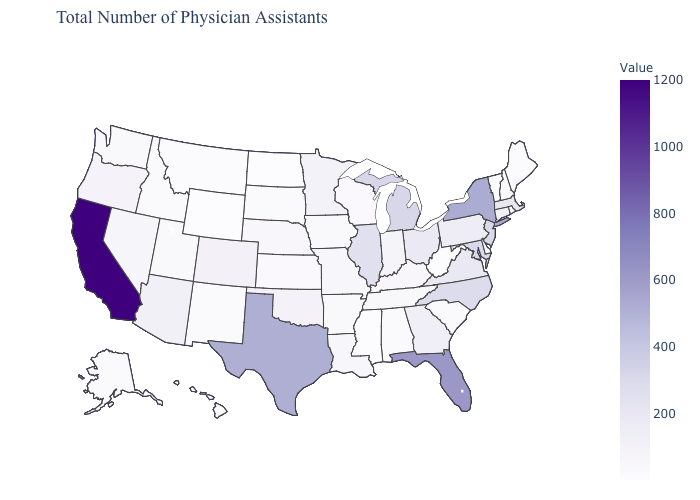Among the states that border Illinois , does Wisconsin have the lowest value?
Answer briefly. Yes. Does the map have missing data?
Concise answer only. No. Does Mississippi have the highest value in the USA?
Be succinct. No. 